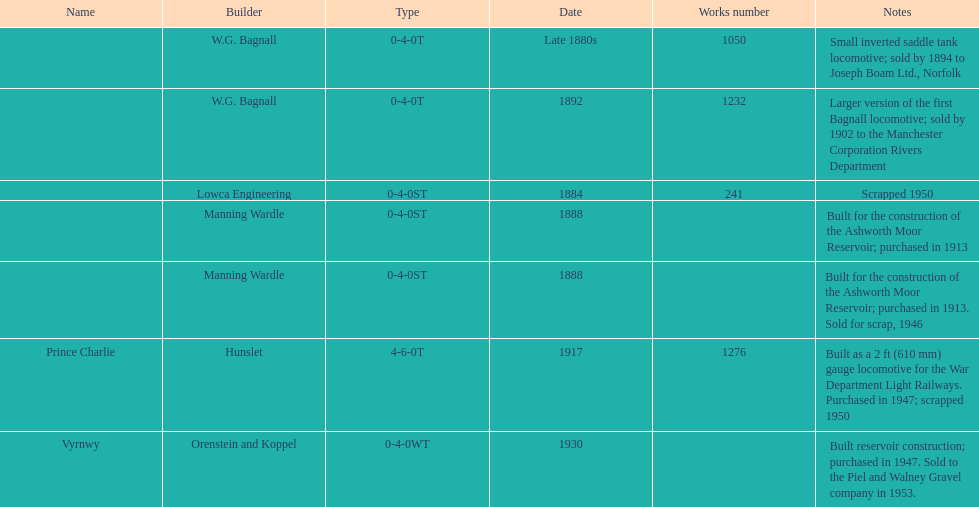How many locomotives were built before the 1900s? 5. 